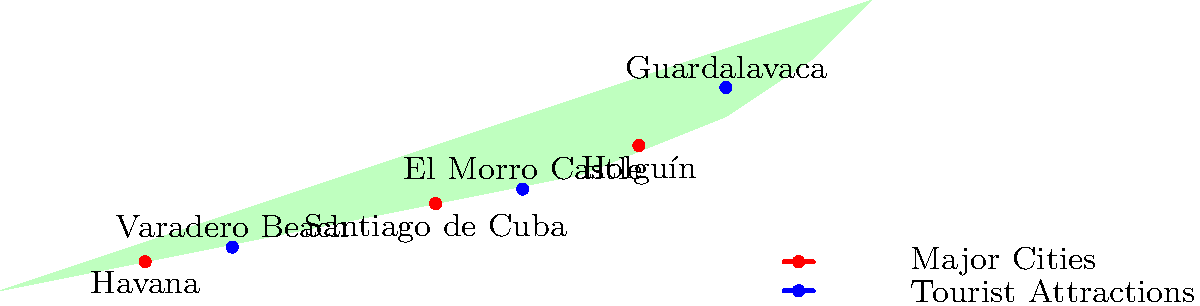Based on the map of Cuba, which major city is geographically closest to the tourist attraction Varadero Beach? To determine which major city is closest to Varadero Beach, we need to follow these steps:

1. Identify the major cities on the map:
   - Havana
   - Santiago de Cuba
   - Holguín

2. Locate Varadero Beach on the map.

3. Visually estimate the distances between Varadero Beach and each major city:
   - Varadero Beach to Havana: This appears to be the shortest distance.
   - Varadero Beach to Santiago de Cuba: This is a much longer distance, spanning almost half the length of the island.
   - Varadero Beach to Holguín: This is also a considerable distance, though slightly less than to Santiago de Cuba.

4. Compare the estimated distances:
   The distance from Varadero Beach to Havana is significantly shorter than the distances to the other two major cities.

5. Conclusion:
   Based on the visual representation on the map, Havana is the major city geographically closest to Varadero Beach.
Answer: Havana 